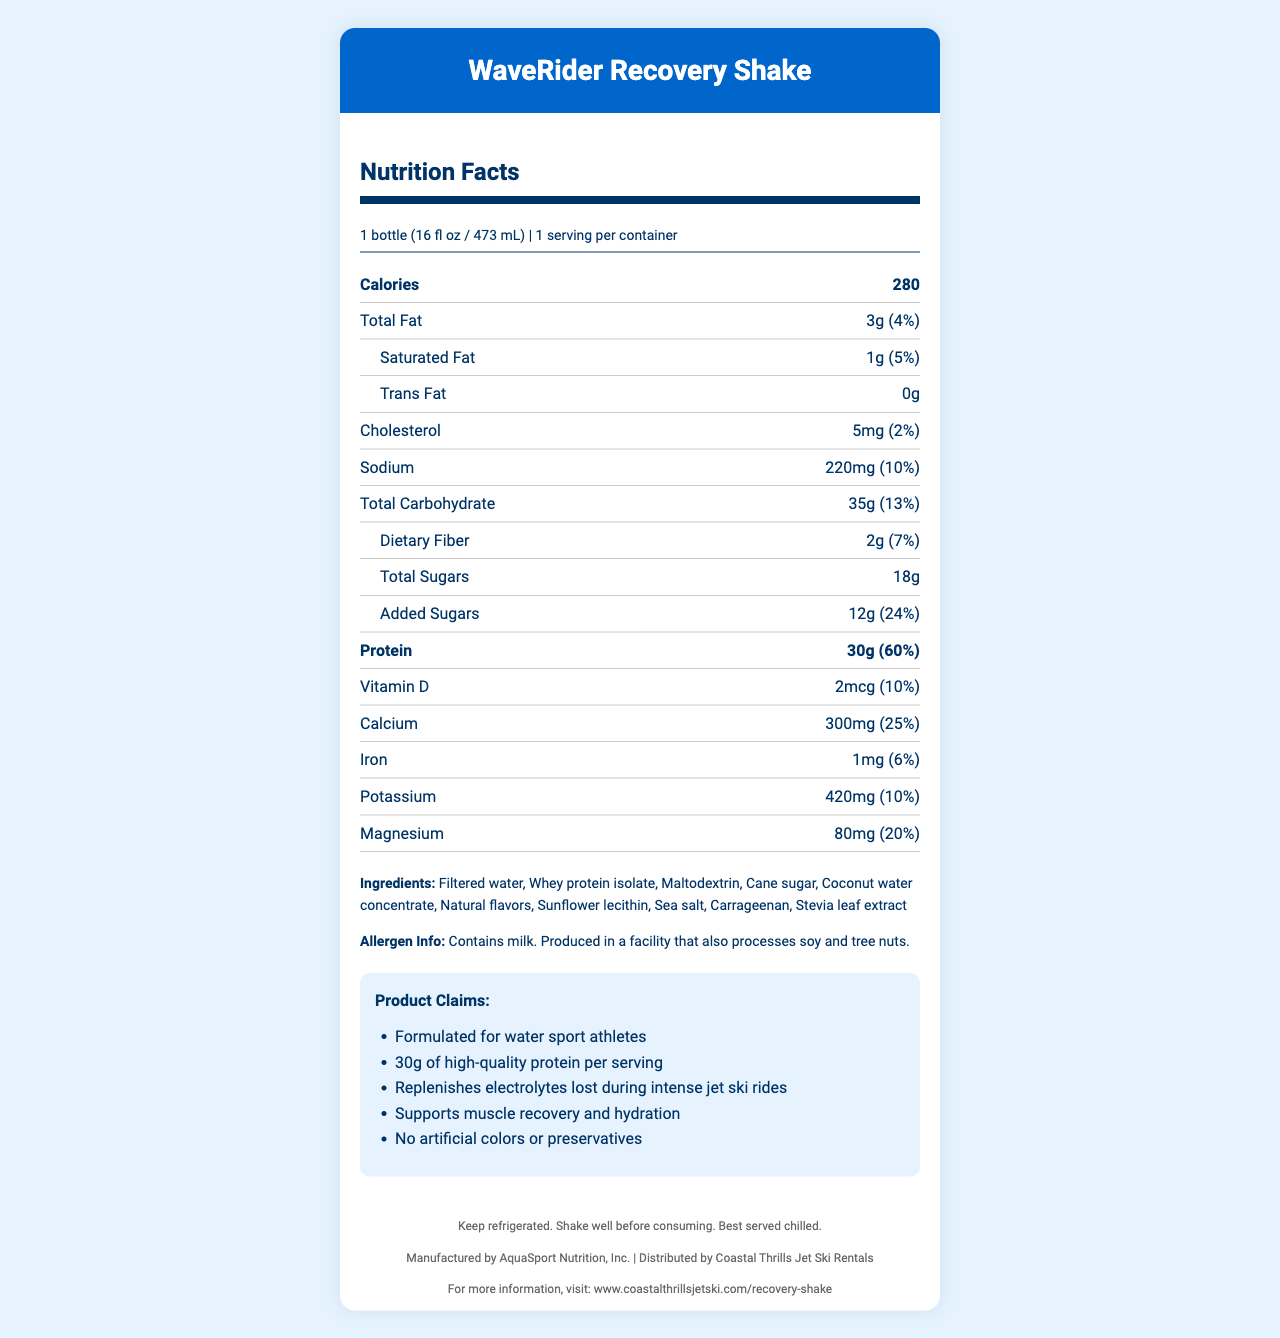what is the serving size for the WaveRider Recovery Shake? The serving size is clearly stated at the top of the Nutrition Facts section as "1 bottle (16 fl oz / 473 mL)".
Answer: 1 bottle (16 fl oz / 473 mL) how many calories does the WaveRider Recovery Shake contain per serving? The document lists the total calories per serving as 280 in the bold section under the nutrition facts.
Answer: 280 calories how much protein is in the WaveRider Recovery Shake? The amount of protein is listed in the bold section as "Protein 30g (60%)" under the nutrition facts.
Answer: 30g what is the daily value percentage for sodium? The daily value percentage for sodium is listed as "10%" in the nutrition facts section.
Answer: 10% list three ingredients in the WaveRider Recovery Shake. The ingredients section lists all the ingredients, including "Filtered water, Whey protein isolate, Maltodextrin".
Answer: Filtered water, Whey protein isolate, Maltodextrin which of the following nutrients has the highest daily value percentage? A. Vitamin D B. Calcium C. Iron D. Magnesium Calcium has a daily value percentage of 25%, which is higher than Vitamin D (10%), Iron (6%), and Magnesium (20%).
Answer: B. Calcium how much added sugar is in the WaveRider Recovery Shake? The amount of added sugars is listed in the nutrition facts section as "Added Sugars 12g (24%)".
Answer: 12g what allergens are present in the WaveRider Recovery Shake? The allergen information states "Contains milk".
Answer: Milk does the WaveRider Recovery Shake contain any artificial colors or preservatives? The product claims section mentions "No artificial colors or preservatives".
Answer: No True or False: The nutrition facts state that there are polyunsaturated fats in the WaveRider Recovery Shake. The document does not list any polyunsaturated fats in the nutrition facts section.
Answer: False summarize the main features and nutritional information of the WaveRider Recovery Shake. The document specifies detailed nutritional information, ingredients, allergen warnings, and claims for the shake, which are summarized in this answer.
Answer: The WaveRider Recovery Shake is a 16 fl oz recovery drink formulated for water sport athletes. It contains 280 calories per serving with 3g of total fat, 5mg of cholesterol, 220mg of sodium, 35g of total carbohydrates, 2g of dietary fiber, 18g of total sugars (including 12g of added sugars), and 30g of protein. The drink also provides several vitamins and minerals such as Vitamin D, calcium, iron, potassium, and magnesium. It's made with no artificial colors or preservatives and contains milk allergens. what is the percentage of daily value for dietary fiber? The percentage of daily value for dietary fiber is listed as "7%" in the nutrition facts section.
Answer: 7% how much magnesium is in the WaveRider Recovery Shake? The amount of magnesium is listed as "Magnesium 80mg (20%)" in the nutrition facts section.
Answer: 80mg what is the website for more information about the WaveRider Recovery Shake? The document provides the website for more information in the footer section.
Answer: www.coastalthrillsjetski.com/recovery-shake is the WaveRider Recovery Shake suitable for someone with a nut allergy? The document states that the product is produced in a facility that also processes tree nuts, but does not specify the exact nut cross-contact risk.
Answer: Not enough information who is the manufacturer of the WaveRider Recovery Shake? The footer section states that the shake is manufactured by AquaSport Nutrition, Inc.
Answer: AquaSport Nutrition, Inc. 